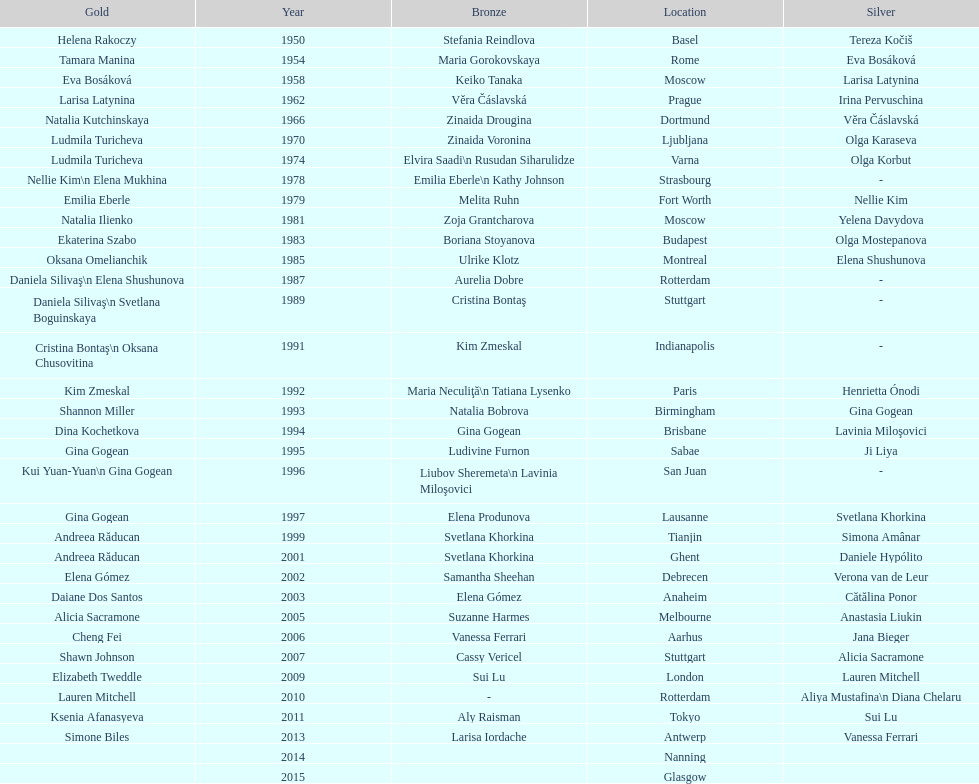Can you parse all the data within this table? {'header': ['Gold', 'Year', 'Bronze', 'Location', 'Silver'], 'rows': [['Helena Rakoczy', '1950', 'Stefania Reindlova', 'Basel', 'Tereza Kočiš'], ['Tamara Manina', '1954', 'Maria Gorokovskaya', 'Rome', 'Eva Bosáková'], ['Eva Bosáková', '1958', 'Keiko Tanaka', 'Moscow', 'Larisa Latynina'], ['Larisa Latynina', '1962', 'Věra Čáslavská', 'Prague', 'Irina Pervuschina'], ['Natalia Kutchinskaya', '1966', 'Zinaida Drougina', 'Dortmund', 'Věra Čáslavská'], ['Ludmila Turicheva', '1970', 'Zinaida Voronina', 'Ljubljana', 'Olga Karaseva'], ['Ludmila Turicheva', '1974', 'Elvira Saadi\\n Rusudan Siharulidze', 'Varna', 'Olga Korbut'], ['Nellie Kim\\n Elena Mukhina', '1978', 'Emilia Eberle\\n Kathy Johnson', 'Strasbourg', '-'], ['Emilia Eberle', '1979', 'Melita Ruhn', 'Fort Worth', 'Nellie Kim'], ['Natalia Ilienko', '1981', 'Zoja Grantcharova', 'Moscow', 'Yelena Davydova'], ['Ekaterina Szabo', '1983', 'Boriana Stoyanova', 'Budapest', 'Olga Mostepanova'], ['Oksana Omelianchik', '1985', 'Ulrike Klotz', 'Montreal', 'Elena Shushunova'], ['Daniela Silivaş\\n Elena Shushunova', '1987', 'Aurelia Dobre', 'Rotterdam', '-'], ['Daniela Silivaş\\n Svetlana Boguinskaya', '1989', 'Cristina Bontaş', 'Stuttgart', '-'], ['Cristina Bontaş\\n Oksana Chusovitina', '1991', 'Kim Zmeskal', 'Indianapolis', '-'], ['Kim Zmeskal', '1992', 'Maria Neculiţă\\n Tatiana Lysenko', 'Paris', 'Henrietta Ónodi'], ['Shannon Miller', '1993', 'Natalia Bobrova', 'Birmingham', 'Gina Gogean'], ['Dina Kochetkova', '1994', 'Gina Gogean', 'Brisbane', 'Lavinia Miloşovici'], ['Gina Gogean', '1995', 'Ludivine Furnon', 'Sabae', 'Ji Liya'], ['Kui Yuan-Yuan\\n Gina Gogean', '1996', 'Liubov Sheremeta\\n Lavinia Miloşovici', 'San Juan', '-'], ['Gina Gogean', '1997', 'Elena Produnova', 'Lausanne', 'Svetlana Khorkina'], ['Andreea Răducan', '1999', 'Svetlana Khorkina', 'Tianjin', 'Simona Amânar'], ['Andreea Răducan', '2001', 'Svetlana Khorkina', 'Ghent', 'Daniele Hypólito'], ['Elena Gómez', '2002', 'Samantha Sheehan', 'Debrecen', 'Verona van de Leur'], ['Daiane Dos Santos', '2003', 'Elena Gómez', 'Anaheim', 'Cătălina Ponor'], ['Alicia Sacramone', '2005', 'Suzanne Harmes', 'Melbourne', 'Anastasia Liukin'], ['Cheng Fei', '2006', 'Vanessa Ferrari', 'Aarhus', 'Jana Bieger'], ['Shawn Johnson', '2007', 'Cassy Vericel', 'Stuttgart', 'Alicia Sacramone'], ['Elizabeth Tweddle', '2009', 'Sui Lu', 'London', 'Lauren Mitchell'], ['Lauren Mitchell', '2010', '-', 'Rotterdam', 'Aliya Mustafina\\n Diana Chelaru'], ['Ksenia Afanasyeva', '2011', 'Aly Raisman', 'Tokyo', 'Sui Lu'], ['Simone Biles', '2013', 'Larisa Iordache', 'Antwerp', 'Vanessa Ferrari'], ['', '2014', '', 'Nanning', ''], ['', '2015', '', 'Glasgow', '']]} Where did the world artistic gymnastics take place before san juan? Sabae. 